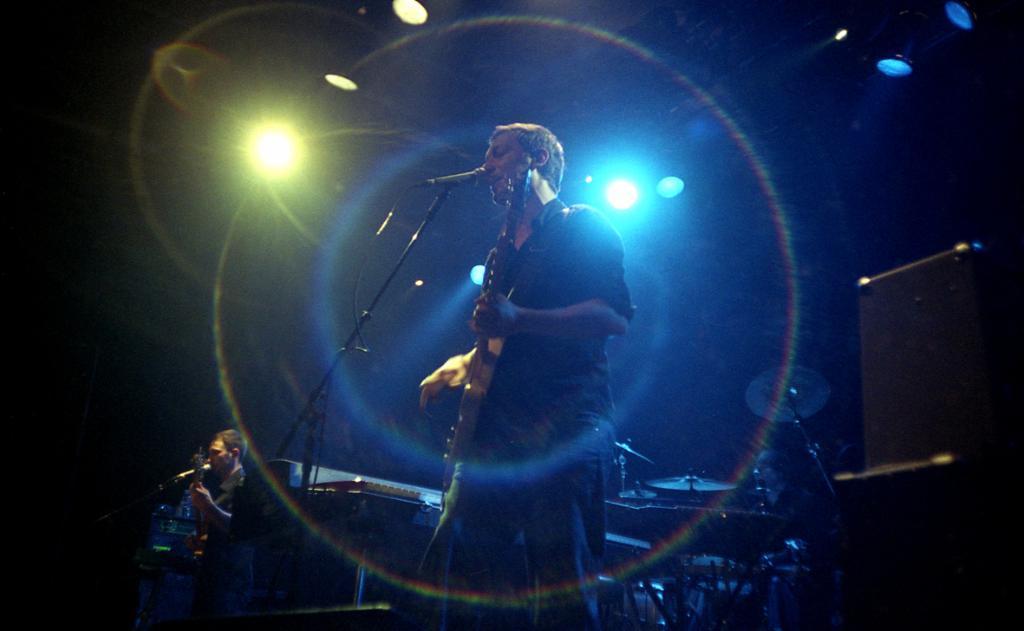In one or two sentences, can you explain what this image depicts? This picture is clicked in a musical concert. The man in black shirt is holding a guitar in his hand. In front of him, we see a microphone and he is singing the song on the microphone. Behind him, we see many musical instruments. On the left side, the man in black shirt is holding a guitar in his hand and he is singing on the microphone. In the background, it is black in color. 